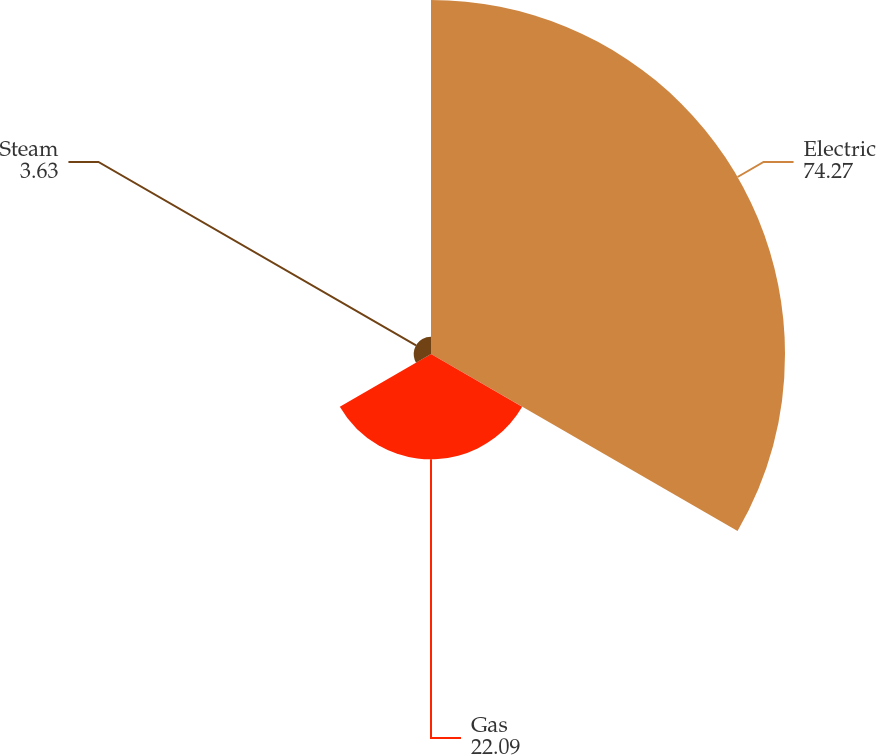Convert chart. <chart><loc_0><loc_0><loc_500><loc_500><pie_chart><fcel>Electric<fcel>Gas<fcel>Steam<nl><fcel>74.27%<fcel>22.09%<fcel>3.63%<nl></chart> 